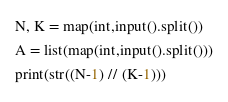<code> <loc_0><loc_0><loc_500><loc_500><_Python_>N, K = map(int,input().split())
A = list(map(int,input().split()))
print(str((N-1) // (K-1)))</code> 